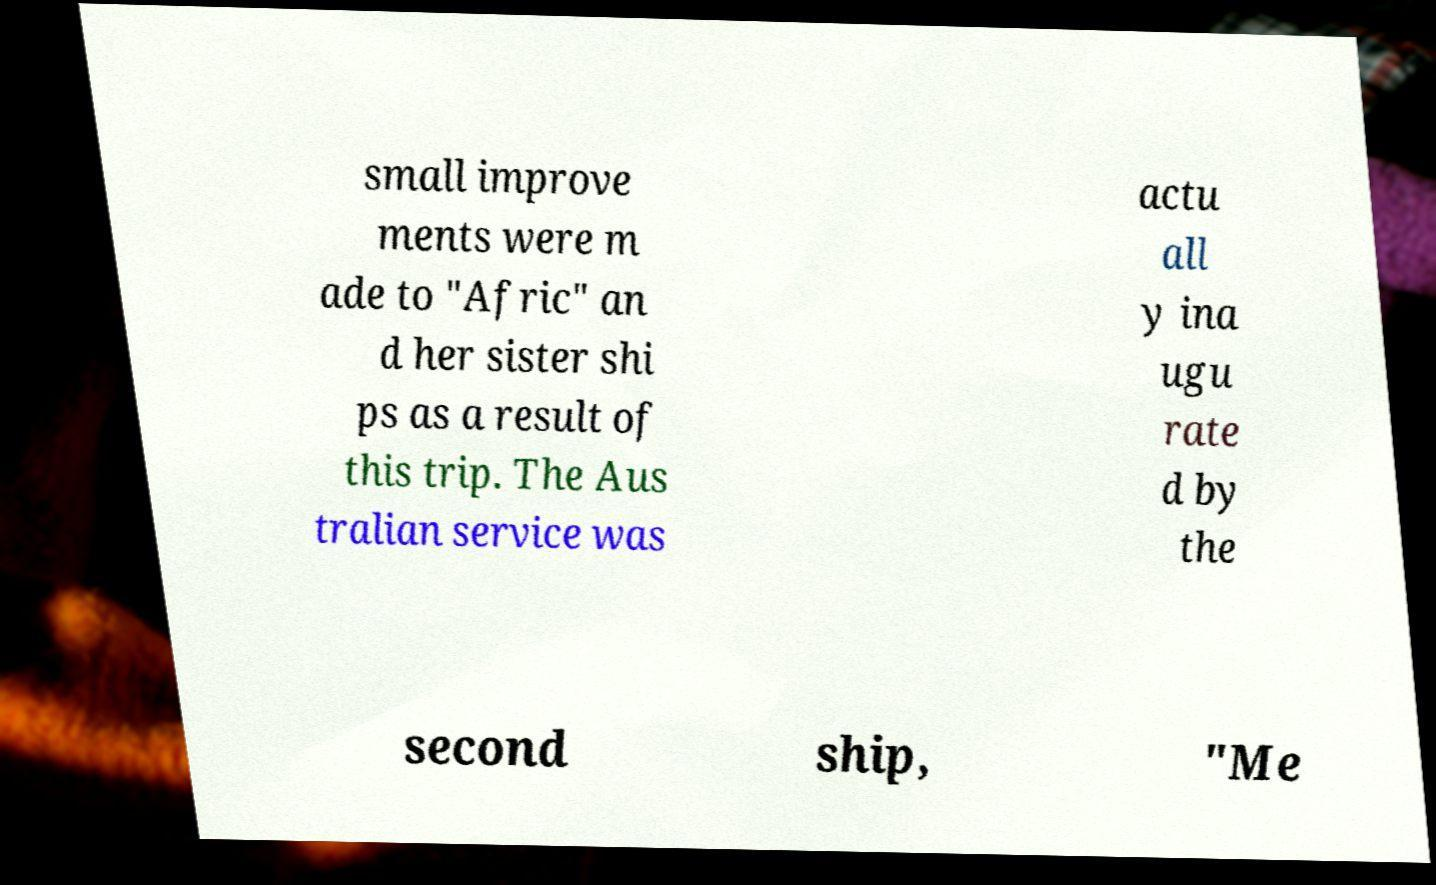For documentation purposes, I need the text within this image transcribed. Could you provide that? small improve ments were m ade to "Afric" an d her sister shi ps as a result of this trip. The Aus tralian service was actu all y ina ugu rate d by the second ship, "Me 